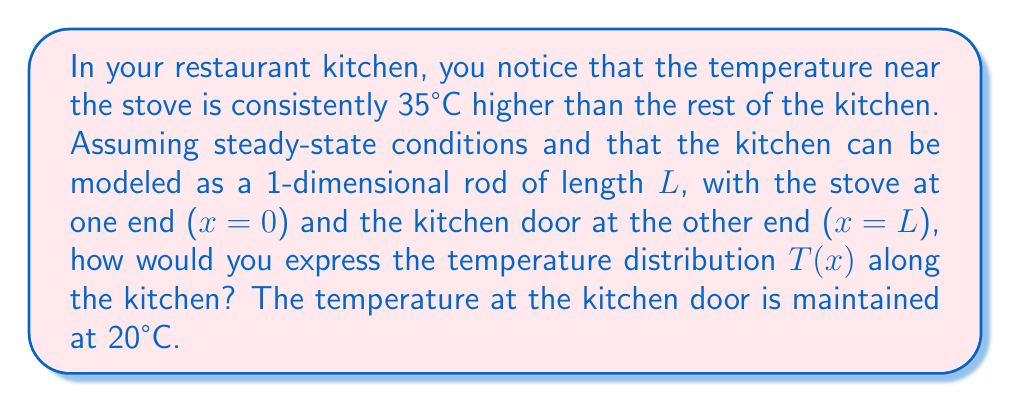What is the answer to this math problem? To model the temperature distribution in the kitchen, we can use the steady-state heat equation in one dimension:

$$\frac{d^2T}{dx^2} = 0$$

The general solution to this equation is:

$$T(x) = Ax + B$$

where A and B are constants we need to determine using the boundary conditions.

Given:
1. At x = 0 (stove), T(0) = 55°C (20°C + 35°C)
2. At x = L (door), T(L) = 20°C

Let's apply these boundary conditions:

1. T(0) = B = 55°C
2. T(L) = AL + B = 20°C

Substituting the value of B from (1) into (2):

$$AL + 55 = 20$$
$$AL = -35$$
$$A = -\frac{35}{L}$$

Therefore, the temperature distribution function is:

$$T(x) = -\frac{35}{L}x + 55$$

This linear function describes how the temperature decreases from 55°C at the stove to 20°C at the door over the length L of the kitchen.
Answer: $$T(x) = -\frac{35}{L}x + 55$$ 